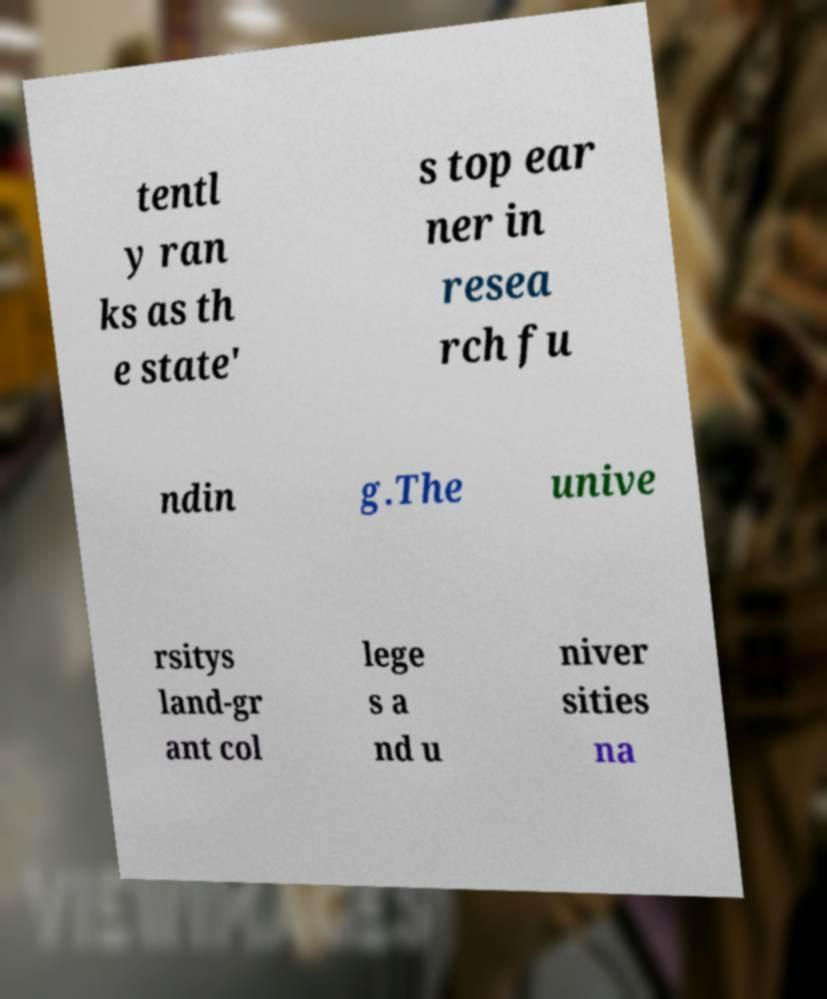Could you assist in decoding the text presented in this image and type it out clearly? tentl y ran ks as th e state' s top ear ner in resea rch fu ndin g.The unive rsitys land-gr ant col lege s a nd u niver sities na 